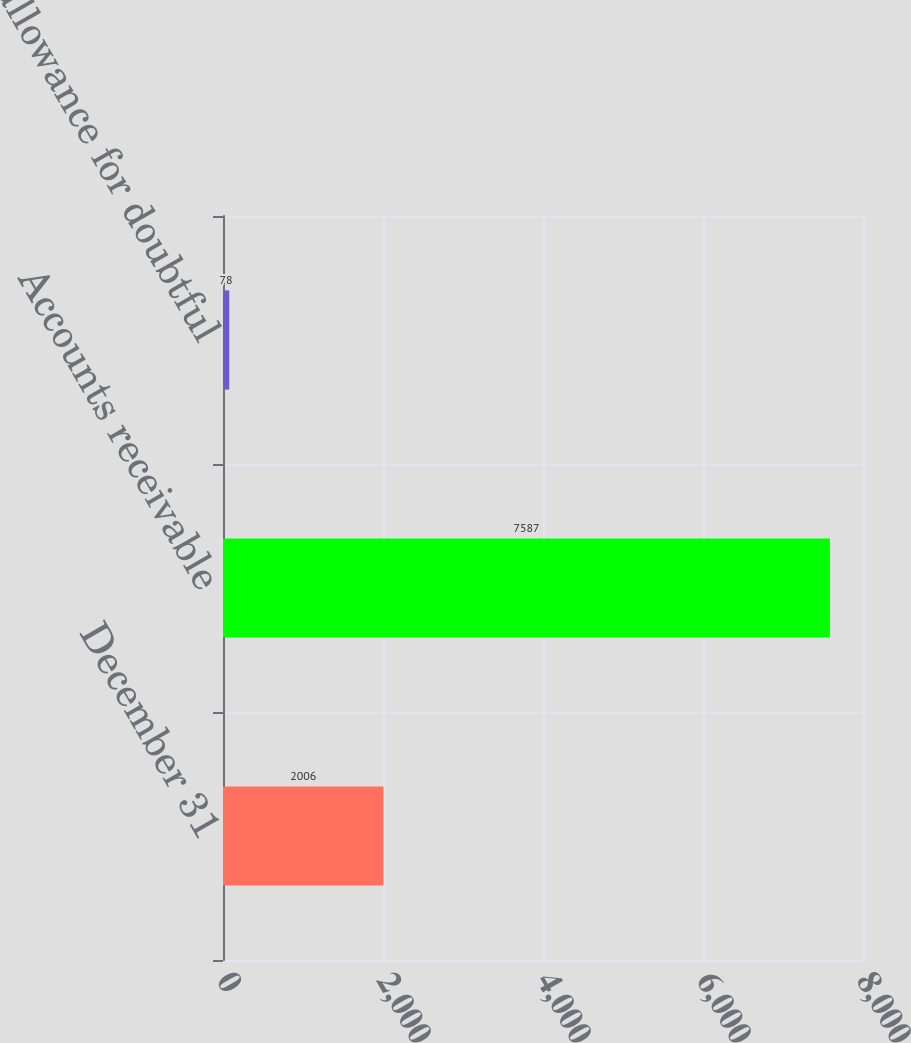Convert chart. <chart><loc_0><loc_0><loc_500><loc_500><bar_chart><fcel>December 31<fcel>Accounts receivable<fcel>Less allowance for doubtful<nl><fcel>2006<fcel>7587<fcel>78<nl></chart> 